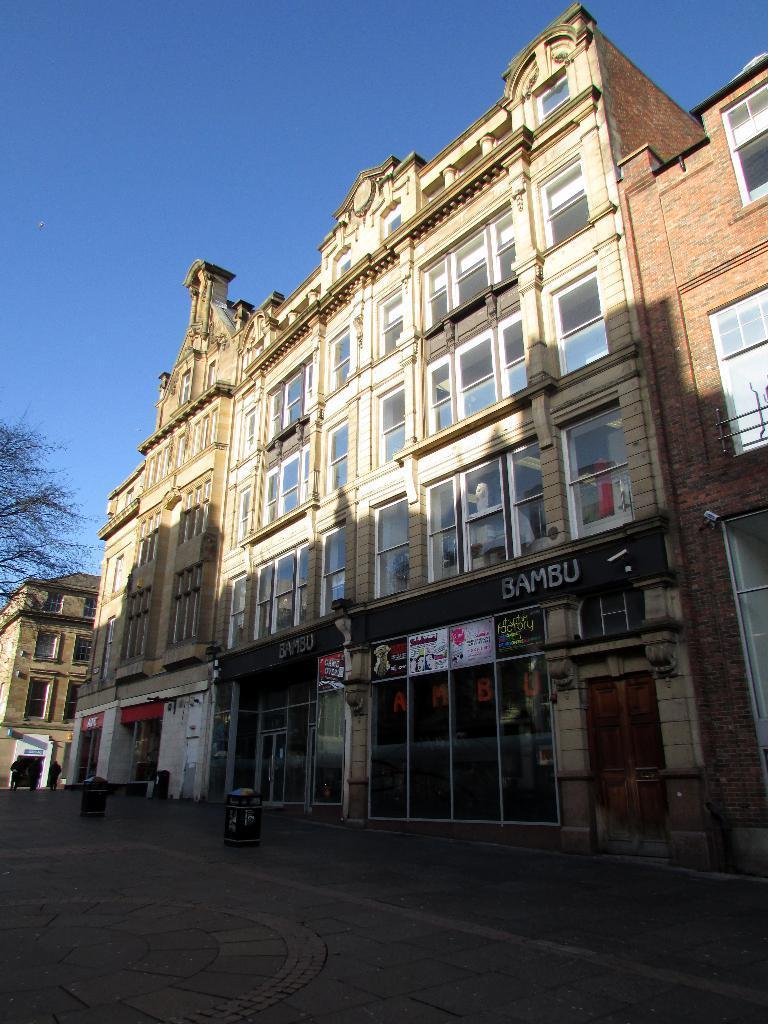Please provide a concise description of this image. In this picture we can see few buildings, hoardings and a tree. 